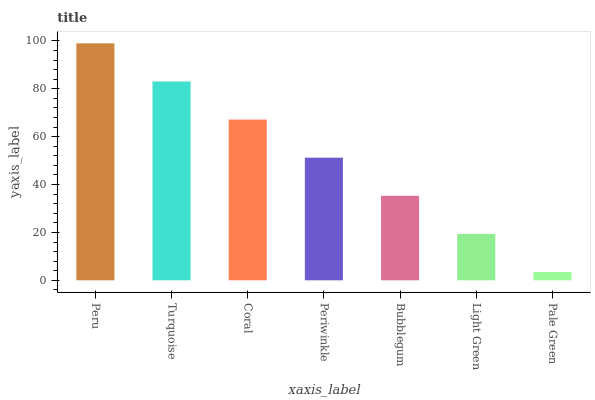Is Turquoise the minimum?
Answer yes or no. No. Is Turquoise the maximum?
Answer yes or no. No. Is Peru greater than Turquoise?
Answer yes or no. Yes. Is Turquoise less than Peru?
Answer yes or no. Yes. Is Turquoise greater than Peru?
Answer yes or no. No. Is Peru less than Turquoise?
Answer yes or no. No. Is Periwinkle the high median?
Answer yes or no. Yes. Is Periwinkle the low median?
Answer yes or no. Yes. Is Coral the high median?
Answer yes or no. No. Is Pale Green the low median?
Answer yes or no. No. 